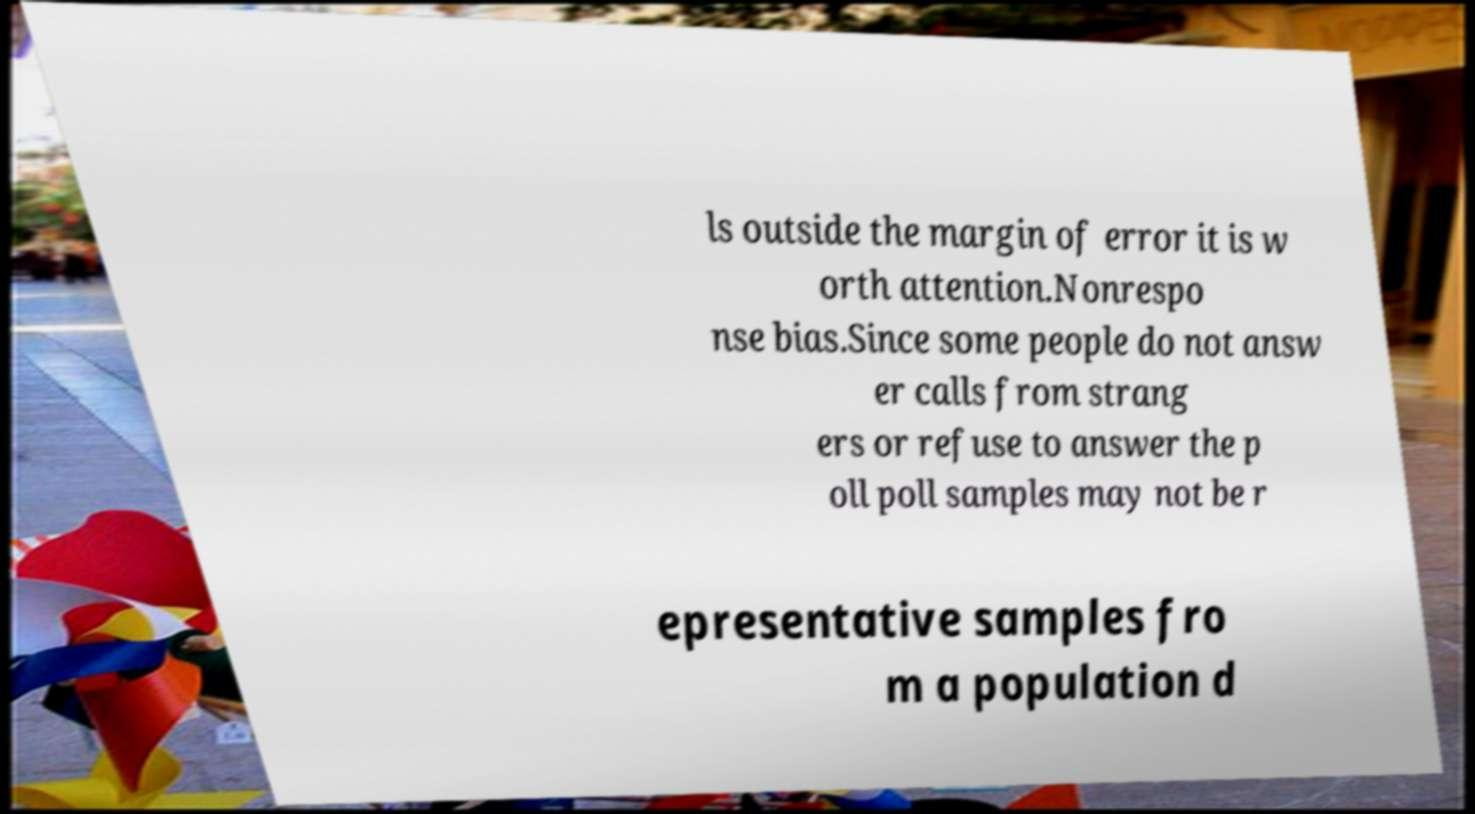Can you read and provide the text displayed in the image?This photo seems to have some interesting text. Can you extract and type it out for me? ls outside the margin of error it is w orth attention.Nonrespo nse bias.Since some people do not answ er calls from strang ers or refuse to answer the p oll poll samples may not be r epresentative samples fro m a population d 